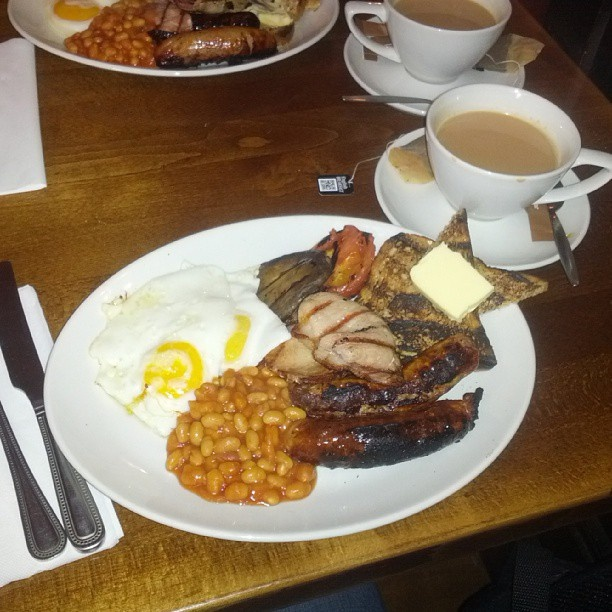Describe the objects in this image and their specific colors. I can see dining table in lightgray, maroon, and olive tones, cup in maroon, lightgray, tan, darkgray, and gray tones, cup in maroon, darkgray, brown, and gray tones, knife in maroon, black, gray, and darkgray tones, and knife in maroon, gray, and black tones in this image. 